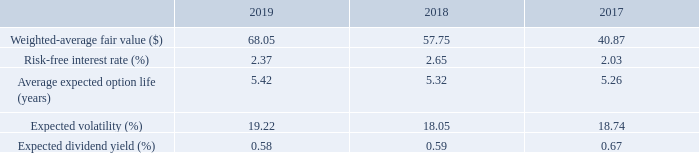Stock Options—Stock options are typically granted at prices not less than 100% of market value of the underlying stock at the date of grant. Stock options typically vest over a period of 3 to 5 years from the grant date and expire 10 years after the grant date. The Company recorded $32.0, $23.2, and $18.3 of compensation expense relating to outstanding options during 2019, 2018 and 2017, respectively, as a component of general and administrative expenses at Corporate.
The Company estimates the fair value of its option awards using the Black-Scholes option valuation model. The stock volatility for each grant is measured using the weighted-average of historical daily price changes of the Company’s common stock over the most recent period equal to the expected life of the grant. The expected term of options granted is derived from historical data to estimate option exercises and employee forfeitures, and represents the period of time that options granted are expected to be outstanding. The risk-free rate for periods within the contractual life of the option is based on the U.S. Treasury yield curve in effect at the time of grant. The weighted-average fair value of options granted in 2019, 2018 and 2017 were calculated using the following weighted-average assumptions:
How are stock options typically granted? At prices not less than 100% of market value of the underlying stock at the date of grant. What were the compensation expenses relating to outstanding options as a component of general and administrative expenses during 2018 and 2019, respectively? $23.2, $32.0. What was the weighted-average fair value of options granted in 2017, 2018, and 2019, respectively? 40.87, 57.75, 68.05. What is the percentage change in the weighted-average fair value of options granted in 2019 compared to 2017?
Answer scale should be: percent. (68.05-40.87)/40.87 
Answer: 66.5. Which year had the highest expected dividend yield? 0.67>0.59>0.58
Answer: 2017. What is the average weighted-average fair value of options granted from 2017 to 2019? (68.05+57.75+40.87)/3 
Answer: 55.56. 